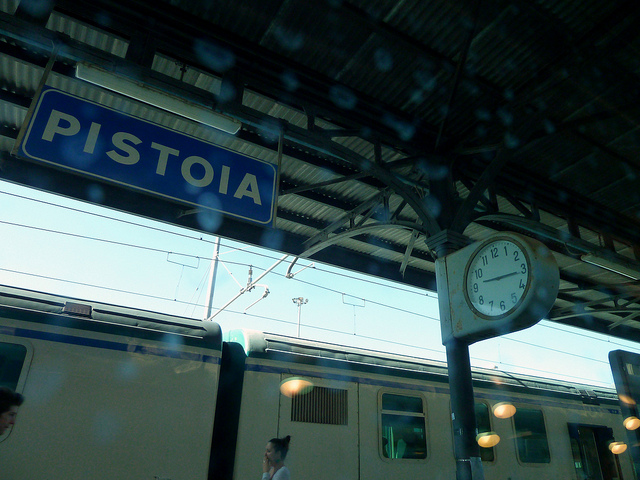Identify the text displayed in this image. PISTOIA 12 11 10 9 2 1 3 4 5 6 8 